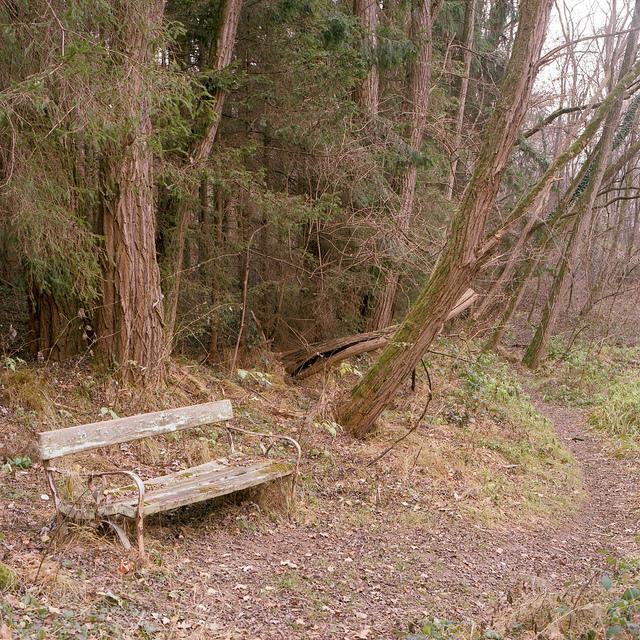Has this bench been neglected?
Concise answer only. Yes. Is the bench facing toward the camera?
Concise answer only. No. What is the bench made of?
Give a very brief answer. Wood. Is the sun shining on the bench?
Write a very short answer. No. Is there a trail?
Write a very short answer. Yes. What are the benches made of?
Answer briefly. Wood. 